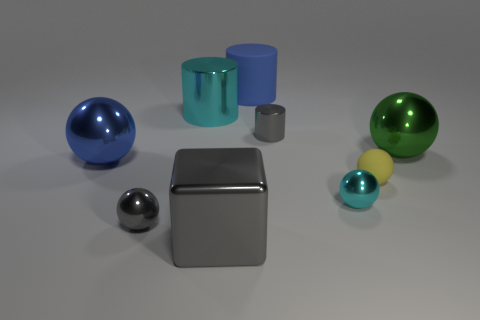Is there a yellow metal sphere that has the same size as the yellow rubber sphere?
Offer a very short reply. No. How many other objects are the same material as the green object?
Your response must be concise. 6. What is the color of the thing that is right of the small cyan sphere and behind the blue metallic sphere?
Make the answer very short. Green. Is the material of the large cylinder that is behind the large cyan metallic cylinder the same as the large cylinder that is on the left side of the block?
Your answer should be compact. No. There is a cyan object to the right of the cyan cylinder; does it have the same size as the yellow rubber sphere?
Keep it short and to the point. Yes. There is a cube; is it the same color as the tiny ball that is on the left side of the tiny cyan metallic object?
Keep it short and to the point. Yes. What is the shape of the object that is the same color as the large rubber cylinder?
Give a very brief answer. Sphere. What is the shape of the small cyan object?
Your response must be concise. Sphere. Is the tiny cylinder the same color as the big metallic cube?
Provide a succinct answer. Yes. What number of things are either large spheres that are on the right side of the yellow object or big gray rubber cylinders?
Ensure brevity in your answer.  1. 